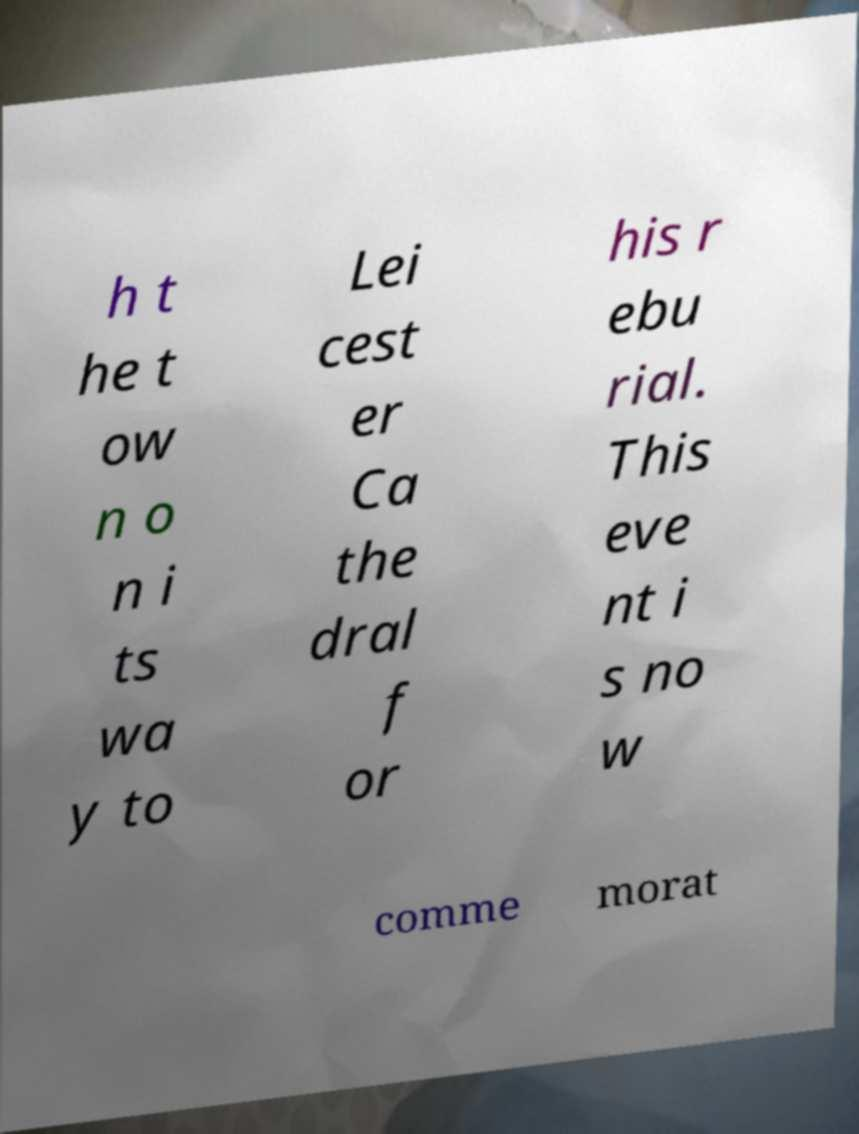For documentation purposes, I need the text within this image transcribed. Could you provide that? h t he t ow n o n i ts wa y to Lei cest er Ca the dral f or his r ebu rial. This eve nt i s no w comme morat 